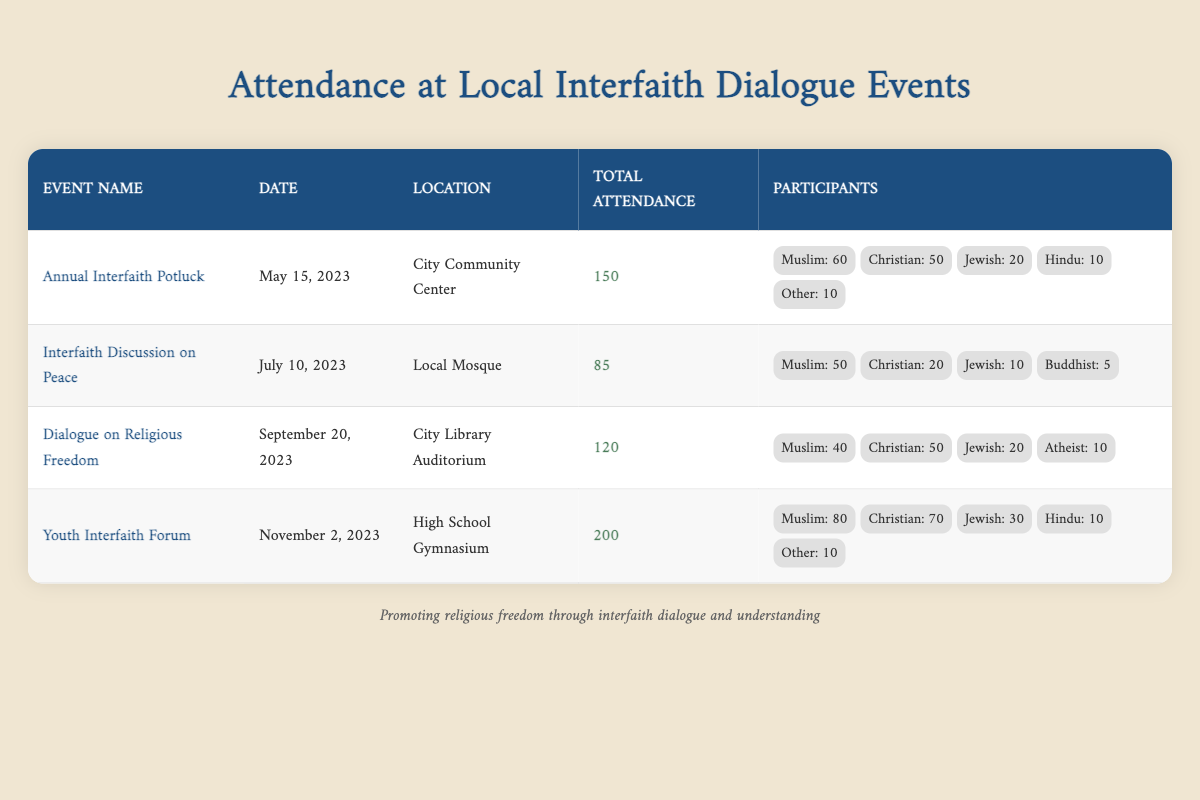What is the total attendance for the Annual Interfaith Potluck? The table states that the attendance for the Annual Interfaith Potluck is 150.
Answer: 150 Which event had the highest attendance and what was that attendance? Reviewing the table, the Youth Interfaith Forum has the highest attendance of 200.
Answer: Youth Interfaith Forum, 200 How many Muslim participants attended the Interfaith Discussion on Peace? According to the table, the Interfaith Discussion on Peace had 50 Muslim participants.
Answer: 50 What is the average attendance across all events listed? The total attendance for all events is 150 + 85 + 120 + 200 = 555. There are 4 events, so the average attendance is 555 / 4 = 138.75.
Answer: 138.75 Did the Dialogue on Religious Freedom have more Christian participants than the Annual Interfaith Potluck? The Dialogue on Religious Freedom had 50 Christian participants while the Annual Interfaith Potluck had 50 Christian participants as well, which means they are equal.
Answer: No How many more attendees were at the Youth Interfaith Forum compared to the Interfaith Discussion on Peace? The Youth Interfaith Forum had 200 attendees while the Interfaith Discussion on Peace had 85 attendees. So, 200 - 85 = 115 more attendees.
Answer: 115 What percentage of the total attendance at the Annual Interfaith Potluck were Muslim participants? In the Annual Interfaith Potluck, there were 60 Muslim participants out of 150 total attendees. The percentage is (60 / 150) * 100 = 40%.
Answer: 40% Which event had the least number of participants from the "Other" category, and how many were there? The Interfaith Discussion on Peace had 0 participants from the "Other" category, which is fewer than any other event.
Answer: Interfaith Discussion on Peace, 0 How many total attendees were from non-Muslim backgrounds across all events? Total non-Muslim attendees can be calculated by summing the non-Muslim participants. This totals to 50 (Christian) + 20 (Jewish) + 10 (Hindu) + 0 (Other) + 20 (Jewish) + 5 (Buddhist) + 70 (Christian) + 30 (Jewish) + 10 (Hindu) + 10 (Other) = 305.
Answer: 305 